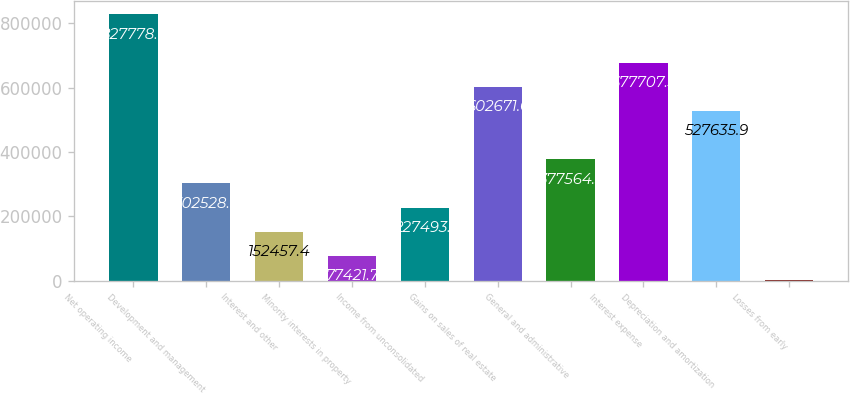<chart> <loc_0><loc_0><loc_500><loc_500><bar_chart><fcel>Net operating income<fcel>Development and management<fcel>Interest and other<fcel>Minority interests in property<fcel>Income from unconsolidated<fcel>Gains on sales of real estate<fcel>General and administrative<fcel>Interest expense<fcel>Depreciation and amortization<fcel>Losses from early<nl><fcel>827779<fcel>302529<fcel>152457<fcel>77421.7<fcel>227493<fcel>602672<fcel>377564<fcel>677707<fcel>527636<fcel>2386<nl></chart> 